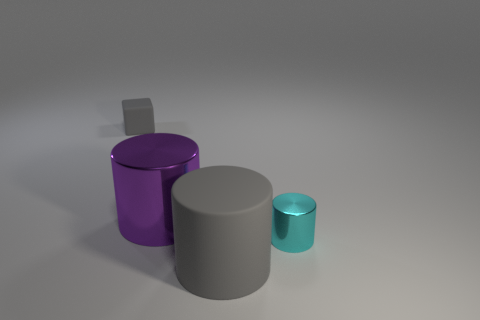What number of matte blocks are the same size as the cyan thing? In the image, there is one matte block—specifically, a grey cylinder—that appears to be the same size as the cyan-colored cylinder. 